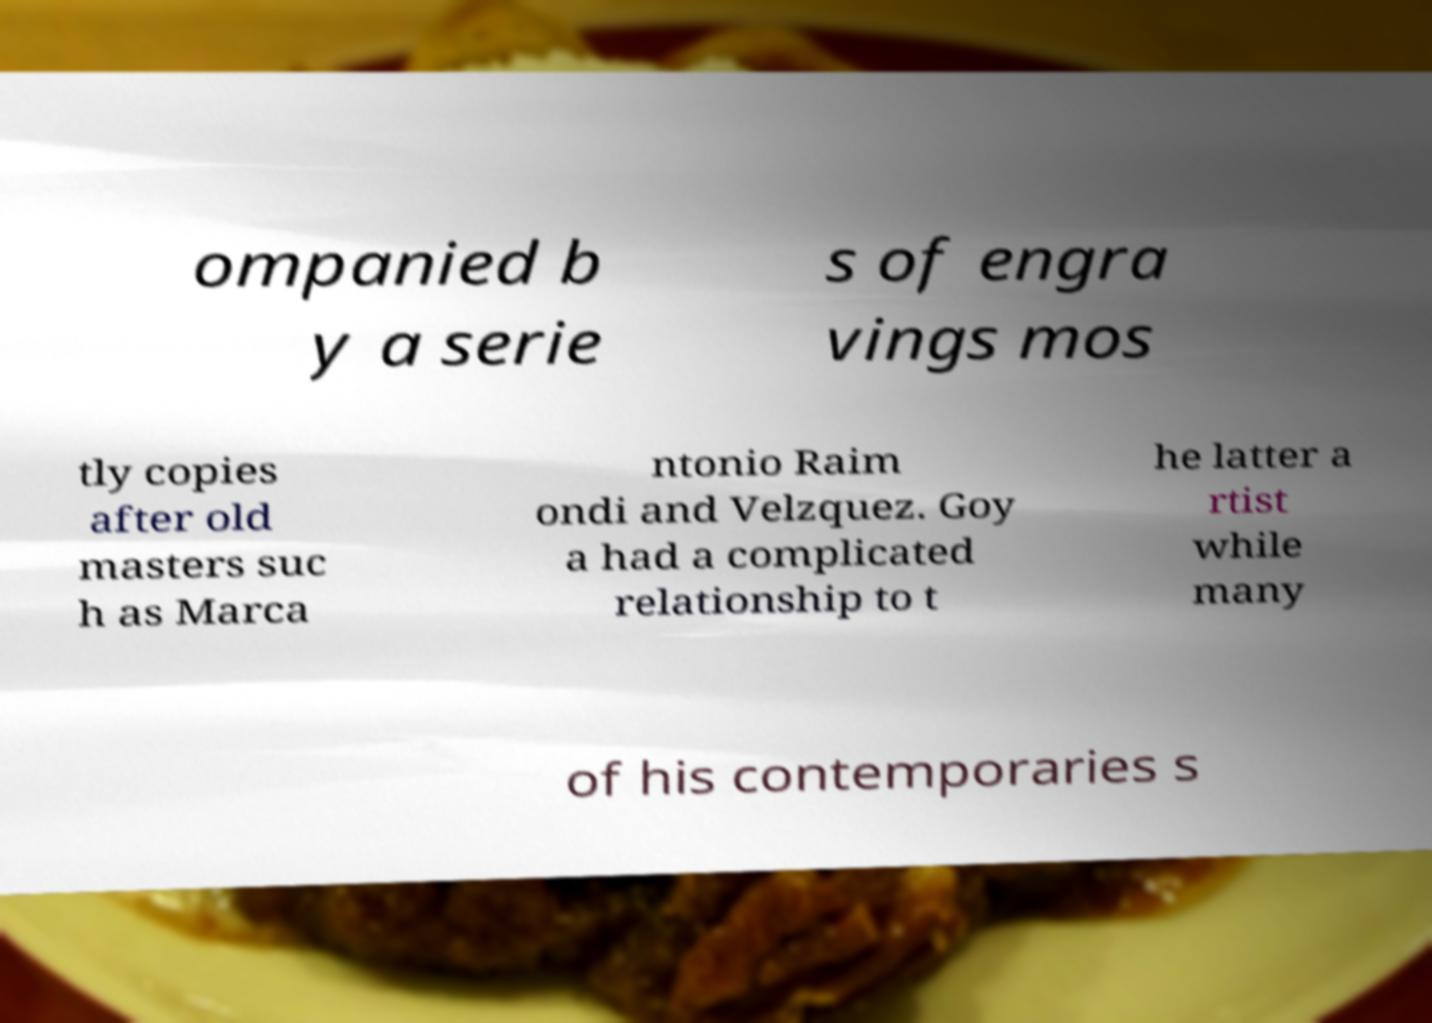Could you assist in decoding the text presented in this image and type it out clearly? ompanied b y a serie s of engra vings mos tly copies after old masters suc h as Marca ntonio Raim ondi and Velzquez. Goy a had a complicated relationship to t he latter a rtist while many of his contemporaries s 